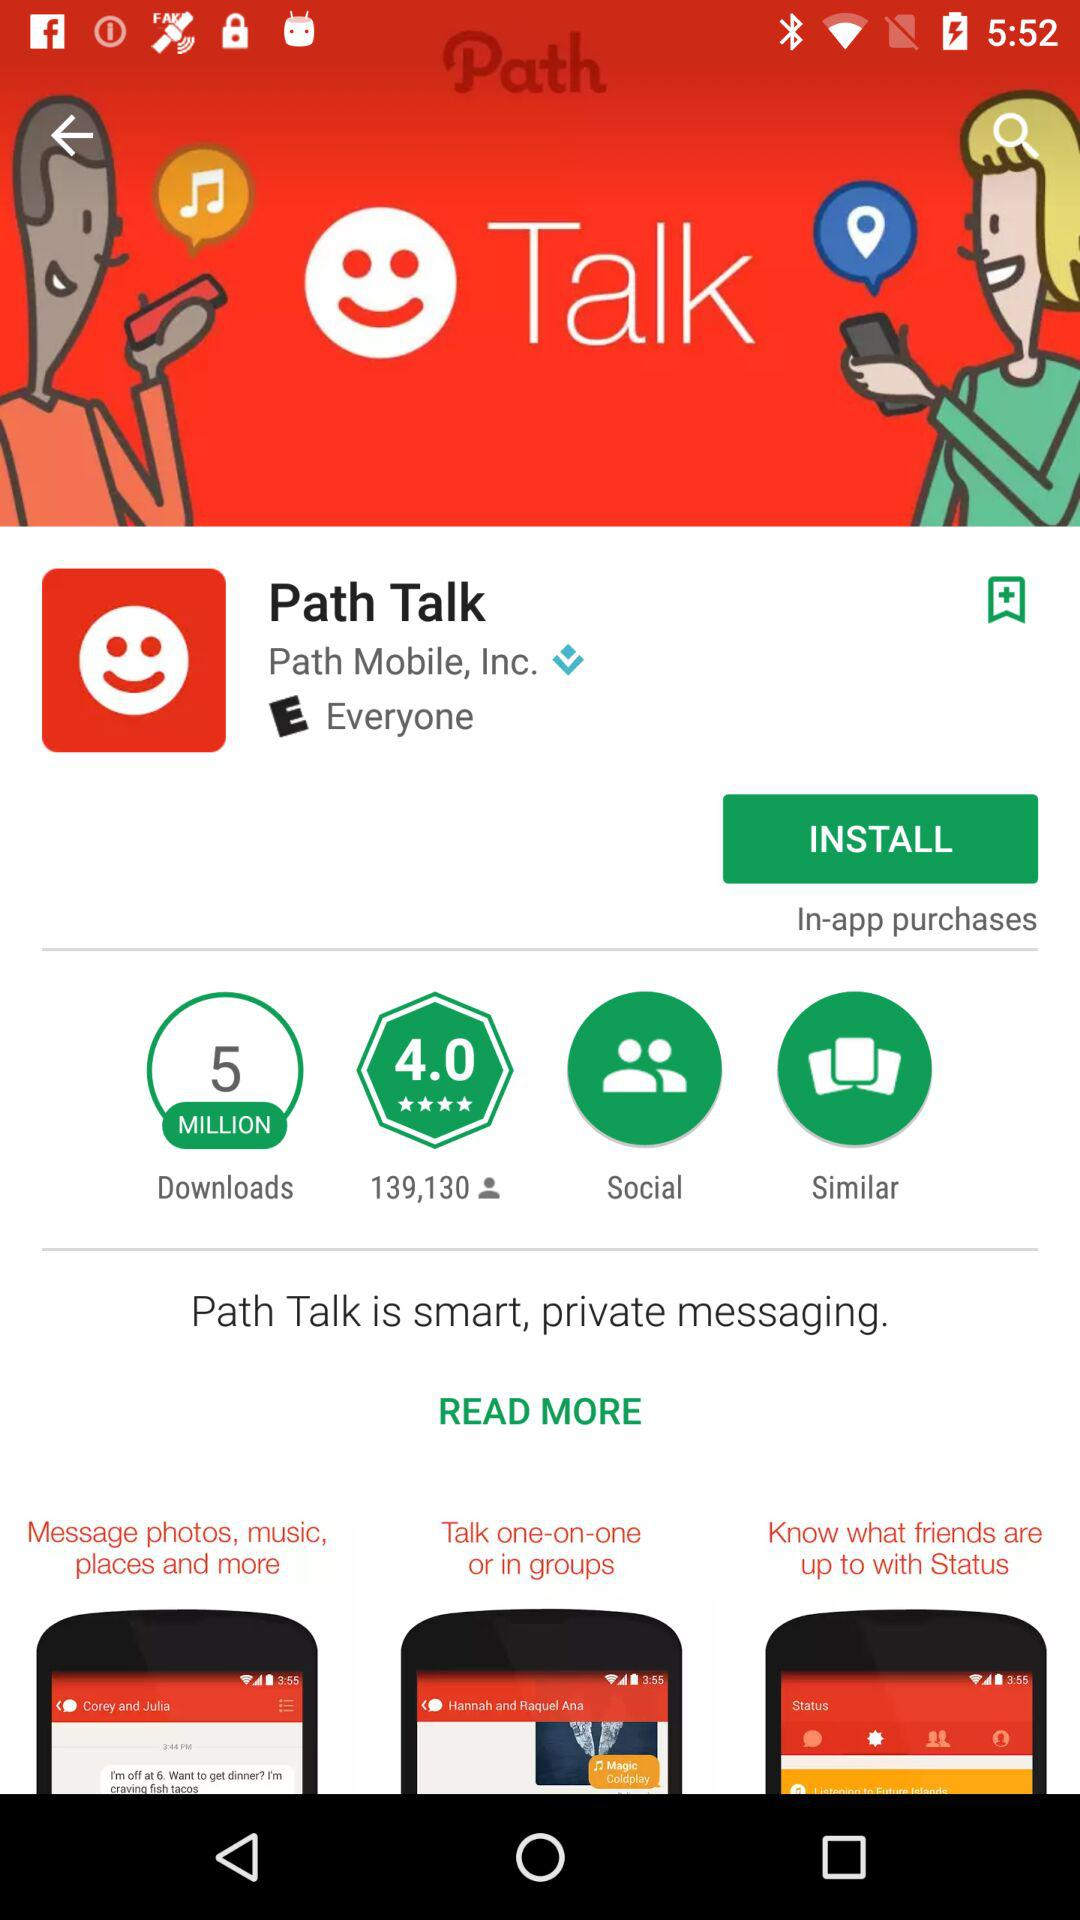What are the number of reviews for this application? There are 139,130 reviews for this application. 